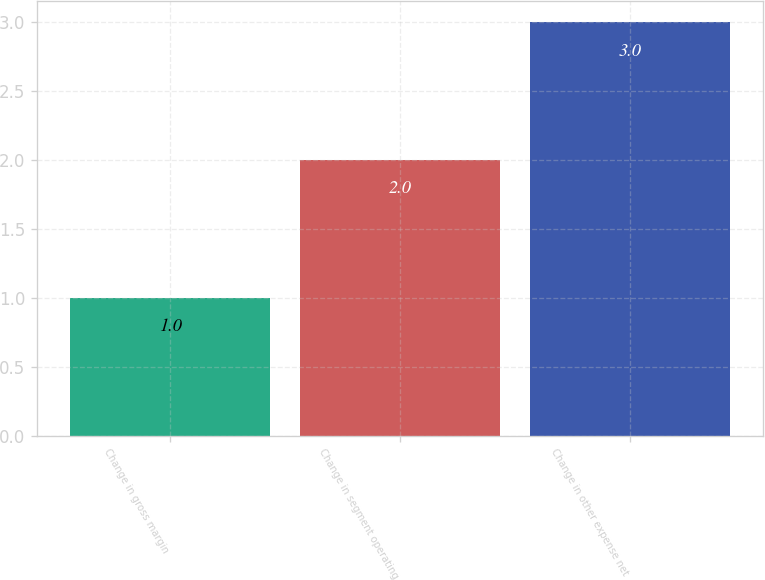Convert chart to OTSL. <chart><loc_0><loc_0><loc_500><loc_500><bar_chart><fcel>Change in gross margin<fcel>Change in segment operating<fcel>Change in other expense net<nl><fcel>1<fcel>2<fcel>3<nl></chart> 